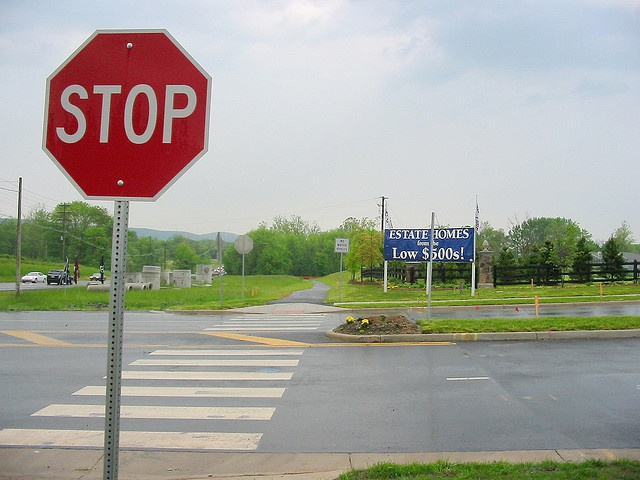Describe the objects in this image and their specific colors. I can see stop sign in darkgray, brown, and maroon tones, car in darkgray, black, gray, and olive tones, car in darkgray, lightgray, gray, and black tones, car in darkgray, black, gray, and lightgray tones, and car in darkgray, gray, and darkgreen tones in this image. 